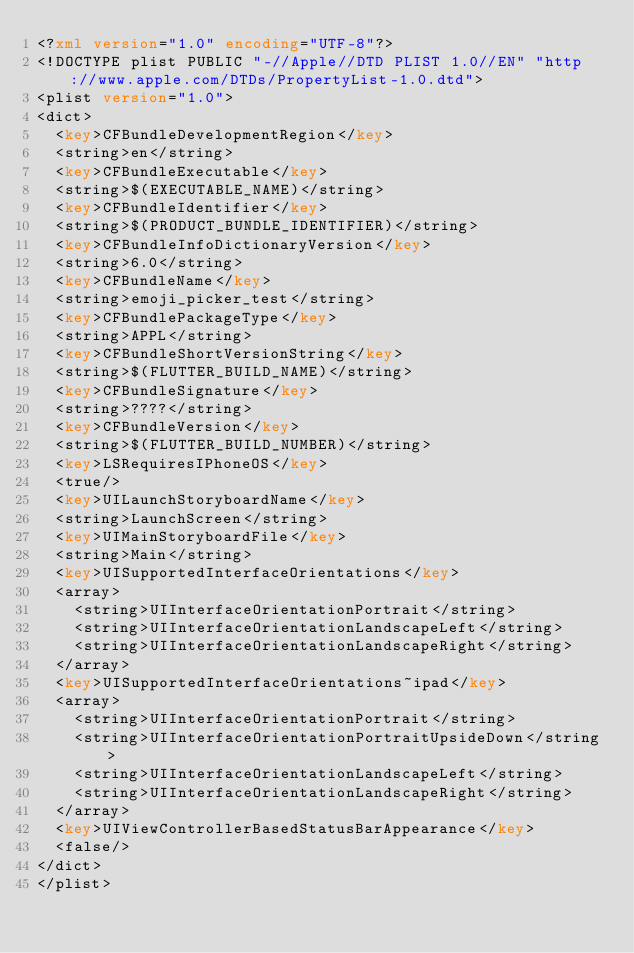Convert code to text. <code><loc_0><loc_0><loc_500><loc_500><_XML_><?xml version="1.0" encoding="UTF-8"?>
<!DOCTYPE plist PUBLIC "-//Apple//DTD PLIST 1.0//EN" "http://www.apple.com/DTDs/PropertyList-1.0.dtd">
<plist version="1.0">
<dict>
	<key>CFBundleDevelopmentRegion</key>
	<string>en</string>
	<key>CFBundleExecutable</key>
	<string>$(EXECUTABLE_NAME)</string>
	<key>CFBundleIdentifier</key>
	<string>$(PRODUCT_BUNDLE_IDENTIFIER)</string>
	<key>CFBundleInfoDictionaryVersion</key>
	<string>6.0</string>
	<key>CFBundleName</key>
	<string>emoji_picker_test</string>
	<key>CFBundlePackageType</key>
	<string>APPL</string>
	<key>CFBundleShortVersionString</key>
	<string>$(FLUTTER_BUILD_NAME)</string>
	<key>CFBundleSignature</key>
	<string>????</string>
	<key>CFBundleVersion</key>
	<string>$(FLUTTER_BUILD_NUMBER)</string>
	<key>LSRequiresIPhoneOS</key>
	<true/>
	<key>UILaunchStoryboardName</key>
	<string>LaunchScreen</string>
	<key>UIMainStoryboardFile</key>
	<string>Main</string>
	<key>UISupportedInterfaceOrientations</key>
	<array>
		<string>UIInterfaceOrientationPortrait</string>
		<string>UIInterfaceOrientationLandscapeLeft</string>
		<string>UIInterfaceOrientationLandscapeRight</string>
	</array>
	<key>UISupportedInterfaceOrientations~ipad</key>
	<array>
		<string>UIInterfaceOrientationPortrait</string>
		<string>UIInterfaceOrientationPortraitUpsideDown</string>
		<string>UIInterfaceOrientationLandscapeLeft</string>
		<string>UIInterfaceOrientationLandscapeRight</string>
	</array>
	<key>UIViewControllerBasedStatusBarAppearance</key>
	<false/>
</dict>
</plist>
</code> 